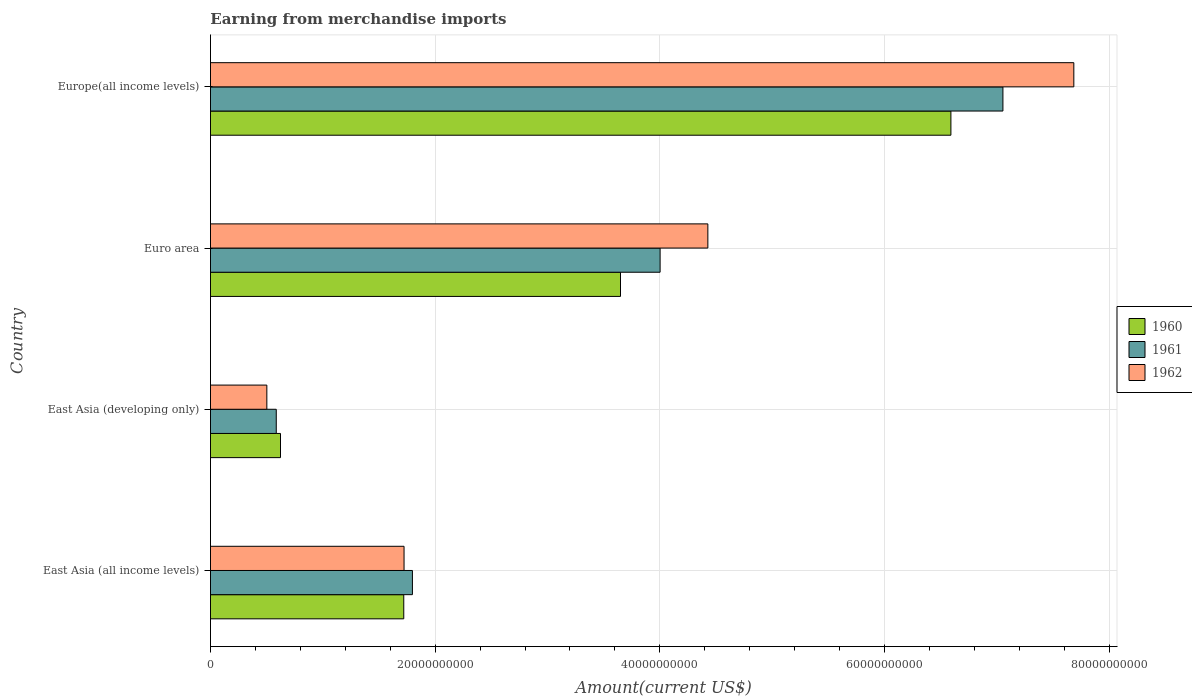How many different coloured bars are there?
Provide a short and direct response. 3. How many bars are there on the 2nd tick from the bottom?
Provide a short and direct response. 3. What is the label of the 2nd group of bars from the top?
Your answer should be very brief. Euro area. In how many cases, is the number of bars for a given country not equal to the number of legend labels?
Your response must be concise. 0. What is the amount earned from merchandise imports in 1961 in East Asia (all income levels)?
Your answer should be very brief. 1.80e+1. Across all countries, what is the maximum amount earned from merchandise imports in 1960?
Provide a succinct answer. 6.59e+1. Across all countries, what is the minimum amount earned from merchandise imports in 1960?
Offer a very short reply. 6.23e+09. In which country was the amount earned from merchandise imports in 1961 maximum?
Offer a terse response. Europe(all income levels). In which country was the amount earned from merchandise imports in 1962 minimum?
Offer a terse response. East Asia (developing only). What is the total amount earned from merchandise imports in 1960 in the graph?
Offer a terse response. 1.26e+11. What is the difference between the amount earned from merchandise imports in 1960 in East Asia (all income levels) and that in Euro area?
Your answer should be very brief. -1.93e+1. What is the difference between the amount earned from merchandise imports in 1960 in Europe(all income levels) and the amount earned from merchandise imports in 1961 in East Asia (developing only)?
Ensure brevity in your answer.  6.01e+1. What is the average amount earned from merchandise imports in 1960 per country?
Your answer should be very brief. 3.15e+1. What is the difference between the amount earned from merchandise imports in 1962 and amount earned from merchandise imports in 1961 in East Asia (developing only)?
Your answer should be very brief. -8.38e+08. In how many countries, is the amount earned from merchandise imports in 1961 greater than 60000000000 US$?
Your response must be concise. 1. What is the ratio of the amount earned from merchandise imports in 1960 in Euro area to that in Europe(all income levels)?
Provide a short and direct response. 0.55. Is the amount earned from merchandise imports in 1962 in Euro area less than that in Europe(all income levels)?
Keep it short and to the point. Yes. What is the difference between the highest and the second highest amount earned from merchandise imports in 1960?
Ensure brevity in your answer.  2.94e+1. What is the difference between the highest and the lowest amount earned from merchandise imports in 1961?
Provide a short and direct response. 6.47e+1. In how many countries, is the amount earned from merchandise imports in 1962 greater than the average amount earned from merchandise imports in 1962 taken over all countries?
Keep it short and to the point. 2. What does the 1st bar from the top in Europe(all income levels) represents?
Provide a short and direct response. 1962. How many bars are there?
Provide a succinct answer. 12. Are the values on the major ticks of X-axis written in scientific E-notation?
Give a very brief answer. No. Where does the legend appear in the graph?
Offer a very short reply. Center right. How many legend labels are there?
Offer a very short reply. 3. How are the legend labels stacked?
Your response must be concise. Vertical. What is the title of the graph?
Keep it short and to the point. Earning from merchandise imports. Does "2008" appear as one of the legend labels in the graph?
Provide a succinct answer. No. What is the label or title of the X-axis?
Keep it short and to the point. Amount(current US$). What is the label or title of the Y-axis?
Give a very brief answer. Country. What is the Amount(current US$) in 1960 in East Asia (all income levels)?
Ensure brevity in your answer.  1.72e+1. What is the Amount(current US$) of 1961 in East Asia (all income levels)?
Give a very brief answer. 1.80e+1. What is the Amount(current US$) of 1962 in East Asia (all income levels)?
Ensure brevity in your answer.  1.72e+1. What is the Amount(current US$) of 1960 in East Asia (developing only)?
Make the answer very short. 6.23e+09. What is the Amount(current US$) of 1961 in East Asia (developing only)?
Provide a succinct answer. 5.86e+09. What is the Amount(current US$) in 1962 in East Asia (developing only)?
Your response must be concise. 5.02e+09. What is the Amount(current US$) in 1960 in Euro area?
Offer a terse response. 3.65e+1. What is the Amount(current US$) of 1961 in Euro area?
Make the answer very short. 4.00e+1. What is the Amount(current US$) of 1962 in Euro area?
Your answer should be very brief. 4.43e+1. What is the Amount(current US$) in 1960 in Europe(all income levels)?
Your response must be concise. 6.59e+1. What is the Amount(current US$) of 1961 in Europe(all income levels)?
Your response must be concise. 7.05e+1. What is the Amount(current US$) of 1962 in Europe(all income levels)?
Give a very brief answer. 7.68e+1. Across all countries, what is the maximum Amount(current US$) in 1960?
Your response must be concise. 6.59e+1. Across all countries, what is the maximum Amount(current US$) in 1961?
Ensure brevity in your answer.  7.05e+1. Across all countries, what is the maximum Amount(current US$) of 1962?
Make the answer very short. 7.68e+1. Across all countries, what is the minimum Amount(current US$) in 1960?
Your answer should be compact. 6.23e+09. Across all countries, what is the minimum Amount(current US$) of 1961?
Provide a short and direct response. 5.86e+09. Across all countries, what is the minimum Amount(current US$) of 1962?
Offer a very short reply. 5.02e+09. What is the total Amount(current US$) of 1960 in the graph?
Offer a very short reply. 1.26e+11. What is the total Amount(current US$) in 1961 in the graph?
Your answer should be very brief. 1.34e+11. What is the total Amount(current US$) of 1962 in the graph?
Your response must be concise. 1.43e+11. What is the difference between the Amount(current US$) of 1960 in East Asia (all income levels) and that in East Asia (developing only)?
Make the answer very short. 1.10e+1. What is the difference between the Amount(current US$) in 1961 in East Asia (all income levels) and that in East Asia (developing only)?
Your response must be concise. 1.21e+1. What is the difference between the Amount(current US$) in 1962 in East Asia (all income levels) and that in East Asia (developing only)?
Offer a terse response. 1.22e+1. What is the difference between the Amount(current US$) of 1960 in East Asia (all income levels) and that in Euro area?
Your answer should be compact. -1.93e+1. What is the difference between the Amount(current US$) in 1961 in East Asia (all income levels) and that in Euro area?
Keep it short and to the point. -2.20e+1. What is the difference between the Amount(current US$) of 1962 in East Asia (all income levels) and that in Euro area?
Give a very brief answer. -2.70e+1. What is the difference between the Amount(current US$) in 1960 in East Asia (all income levels) and that in Europe(all income levels)?
Your answer should be compact. -4.87e+1. What is the difference between the Amount(current US$) in 1961 in East Asia (all income levels) and that in Europe(all income levels)?
Ensure brevity in your answer.  -5.26e+1. What is the difference between the Amount(current US$) in 1962 in East Asia (all income levels) and that in Europe(all income levels)?
Make the answer very short. -5.96e+1. What is the difference between the Amount(current US$) of 1960 in East Asia (developing only) and that in Euro area?
Offer a terse response. -3.03e+1. What is the difference between the Amount(current US$) of 1961 in East Asia (developing only) and that in Euro area?
Offer a very short reply. -3.42e+1. What is the difference between the Amount(current US$) in 1962 in East Asia (developing only) and that in Euro area?
Provide a short and direct response. -3.93e+1. What is the difference between the Amount(current US$) in 1960 in East Asia (developing only) and that in Europe(all income levels)?
Offer a terse response. -5.97e+1. What is the difference between the Amount(current US$) in 1961 in East Asia (developing only) and that in Europe(all income levels)?
Make the answer very short. -6.47e+1. What is the difference between the Amount(current US$) of 1962 in East Asia (developing only) and that in Europe(all income levels)?
Offer a very short reply. -7.18e+1. What is the difference between the Amount(current US$) in 1960 in Euro area and that in Europe(all income levels)?
Offer a very short reply. -2.94e+1. What is the difference between the Amount(current US$) of 1961 in Euro area and that in Europe(all income levels)?
Give a very brief answer. -3.05e+1. What is the difference between the Amount(current US$) of 1962 in Euro area and that in Europe(all income levels)?
Provide a succinct answer. -3.26e+1. What is the difference between the Amount(current US$) of 1960 in East Asia (all income levels) and the Amount(current US$) of 1961 in East Asia (developing only)?
Offer a terse response. 1.13e+1. What is the difference between the Amount(current US$) of 1960 in East Asia (all income levels) and the Amount(current US$) of 1962 in East Asia (developing only)?
Ensure brevity in your answer.  1.22e+1. What is the difference between the Amount(current US$) in 1961 in East Asia (all income levels) and the Amount(current US$) in 1962 in East Asia (developing only)?
Keep it short and to the point. 1.30e+1. What is the difference between the Amount(current US$) of 1960 in East Asia (all income levels) and the Amount(current US$) of 1961 in Euro area?
Your answer should be very brief. -2.28e+1. What is the difference between the Amount(current US$) of 1960 in East Asia (all income levels) and the Amount(current US$) of 1962 in Euro area?
Provide a succinct answer. -2.71e+1. What is the difference between the Amount(current US$) in 1961 in East Asia (all income levels) and the Amount(current US$) in 1962 in Euro area?
Your answer should be compact. -2.63e+1. What is the difference between the Amount(current US$) of 1960 in East Asia (all income levels) and the Amount(current US$) of 1961 in Europe(all income levels)?
Your answer should be very brief. -5.33e+1. What is the difference between the Amount(current US$) of 1960 in East Asia (all income levels) and the Amount(current US$) of 1962 in Europe(all income levels)?
Keep it short and to the point. -5.96e+1. What is the difference between the Amount(current US$) in 1961 in East Asia (all income levels) and the Amount(current US$) in 1962 in Europe(all income levels)?
Offer a very short reply. -5.89e+1. What is the difference between the Amount(current US$) in 1960 in East Asia (developing only) and the Amount(current US$) in 1961 in Euro area?
Offer a very short reply. -3.38e+1. What is the difference between the Amount(current US$) of 1960 in East Asia (developing only) and the Amount(current US$) of 1962 in Euro area?
Make the answer very short. -3.80e+1. What is the difference between the Amount(current US$) in 1961 in East Asia (developing only) and the Amount(current US$) in 1962 in Euro area?
Your answer should be compact. -3.84e+1. What is the difference between the Amount(current US$) of 1960 in East Asia (developing only) and the Amount(current US$) of 1961 in Europe(all income levels)?
Your response must be concise. -6.43e+1. What is the difference between the Amount(current US$) of 1960 in East Asia (developing only) and the Amount(current US$) of 1962 in Europe(all income levels)?
Your response must be concise. -7.06e+1. What is the difference between the Amount(current US$) of 1961 in East Asia (developing only) and the Amount(current US$) of 1962 in Europe(all income levels)?
Make the answer very short. -7.10e+1. What is the difference between the Amount(current US$) of 1960 in Euro area and the Amount(current US$) of 1961 in Europe(all income levels)?
Give a very brief answer. -3.40e+1. What is the difference between the Amount(current US$) of 1960 in Euro area and the Amount(current US$) of 1962 in Europe(all income levels)?
Offer a very short reply. -4.04e+1. What is the difference between the Amount(current US$) in 1961 in Euro area and the Amount(current US$) in 1962 in Europe(all income levels)?
Keep it short and to the point. -3.68e+1. What is the average Amount(current US$) in 1960 per country?
Offer a terse response. 3.15e+1. What is the average Amount(current US$) in 1961 per country?
Make the answer very short. 3.36e+1. What is the average Amount(current US$) in 1962 per country?
Provide a short and direct response. 3.58e+1. What is the difference between the Amount(current US$) of 1960 and Amount(current US$) of 1961 in East Asia (all income levels)?
Provide a short and direct response. -7.70e+08. What is the difference between the Amount(current US$) of 1960 and Amount(current US$) of 1962 in East Asia (all income levels)?
Provide a short and direct response. -2.54e+07. What is the difference between the Amount(current US$) in 1961 and Amount(current US$) in 1962 in East Asia (all income levels)?
Give a very brief answer. 7.44e+08. What is the difference between the Amount(current US$) in 1960 and Amount(current US$) in 1961 in East Asia (developing only)?
Offer a very short reply. 3.78e+08. What is the difference between the Amount(current US$) in 1960 and Amount(current US$) in 1962 in East Asia (developing only)?
Ensure brevity in your answer.  1.22e+09. What is the difference between the Amount(current US$) of 1961 and Amount(current US$) of 1962 in East Asia (developing only)?
Your answer should be very brief. 8.38e+08. What is the difference between the Amount(current US$) in 1960 and Amount(current US$) in 1961 in Euro area?
Keep it short and to the point. -3.53e+09. What is the difference between the Amount(current US$) in 1960 and Amount(current US$) in 1962 in Euro area?
Offer a very short reply. -7.78e+09. What is the difference between the Amount(current US$) in 1961 and Amount(current US$) in 1962 in Euro area?
Offer a very short reply. -4.25e+09. What is the difference between the Amount(current US$) in 1960 and Amount(current US$) in 1961 in Europe(all income levels)?
Ensure brevity in your answer.  -4.63e+09. What is the difference between the Amount(current US$) of 1960 and Amount(current US$) of 1962 in Europe(all income levels)?
Give a very brief answer. -1.09e+1. What is the difference between the Amount(current US$) in 1961 and Amount(current US$) in 1962 in Europe(all income levels)?
Give a very brief answer. -6.31e+09. What is the ratio of the Amount(current US$) in 1960 in East Asia (all income levels) to that in East Asia (developing only)?
Offer a terse response. 2.76. What is the ratio of the Amount(current US$) of 1961 in East Asia (all income levels) to that in East Asia (developing only)?
Offer a very short reply. 3.07. What is the ratio of the Amount(current US$) in 1962 in East Asia (all income levels) to that in East Asia (developing only)?
Provide a short and direct response. 3.43. What is the ratio of the Amount(current US$) of 1960 in East Asia (all income levels) to that in Euro area?
Make the answer very short. 0.47. What is the ratio of the Amount(current US$) in 1961 in East Asia (all income levels) to that in Euro area?
Make the answer very short. 0.45. What is the ratio of the Amount(current US$) in 1962 in East Asia (all income levels) to that in Euro area?
Provide a succinct answer. 0.39. What is the ratio of the Amount(current US$) in 1960 in East Asia (all income levels) to that in Europe(all income levels)?
Give a very brief answer. 0.26. What is the ratio of the Amount(current US$) in 1961 in East Asia (all income levels) to that in Europe(all income levels)?
Provide a succinct answer. 0.25. What is the ratio of the Amount(current US$) in 1962 in East Asia (all income levels) to that in Europe(all income levels)?
Ensure brevity in your answer.  0.22. What is the ratio of the Amount(current US$) of 1960 in East Asia (developing only) to that in Euro area?
Provide a short and direct response. 0.17. What is the ratio of the Amount(current US$) in 1961 in East Asia (developing only) to that in Euro area?
Provide a short and direct response. 0.15. What is the ratio of the Amount(current US$) in 1962 in East Asia (developing only) to that in Euro area?
Keep it short and to the point. 0.11. What is the ratio of the Amount(current US$) of 1960 in East Asia (developing only) to that in Europe(all income levels)?
Provide a succinct answer. 0.09. What is the ratio of the Amount(current US$) of 1961 in East Asia (developing only) to that in Europe(all income levels)?
Keep it short and to the point. 0.08. What is the ratio of the Amount(current US$) in 1962 in East Asia (developing only) to that in Europe(all income levels)?
Keep it short and to the point. 0.07. What is the ratio of the Amount(current US$) in 1960 in Euro area to that in Europe(all income levels)?
Give a very brief answer. 0.55. What is the ratio of the Amount(current US$) of 1961 in Euro area to that in Europe(all income levels)?
Give a very brief answer. 0.57. What is the ratio of the Amount(current US$) in 1962 in Euro area to that in Europe(all income levels)?
Give a very brief answer. 0.58. What is the difference between the highest and the second highest Amount(current US$) in 1960?
Offer a terse response. 2.94e+1. What is the difference between the highest and the second highest Amount(current US$) in 1961?
Your answer should be very brief. 3.05e+1. What is the difference between the highest and the second highest Amount(current US$) in 1962?
Make the answer very short. 3.26e+1. What is the difference between the highest and the lowest Amount(current US$) in 1960?
Ensure brevity in your answer.  5.97e+1. What is the difference between the highest and the lowest Amount(current US$) of 1961?
Your answer should be very brief. 6.47e+1. What is the difference between the highest and the lowest Amount(current US$) in 1962?
Provide a short and direct response. 7.18e+1. 